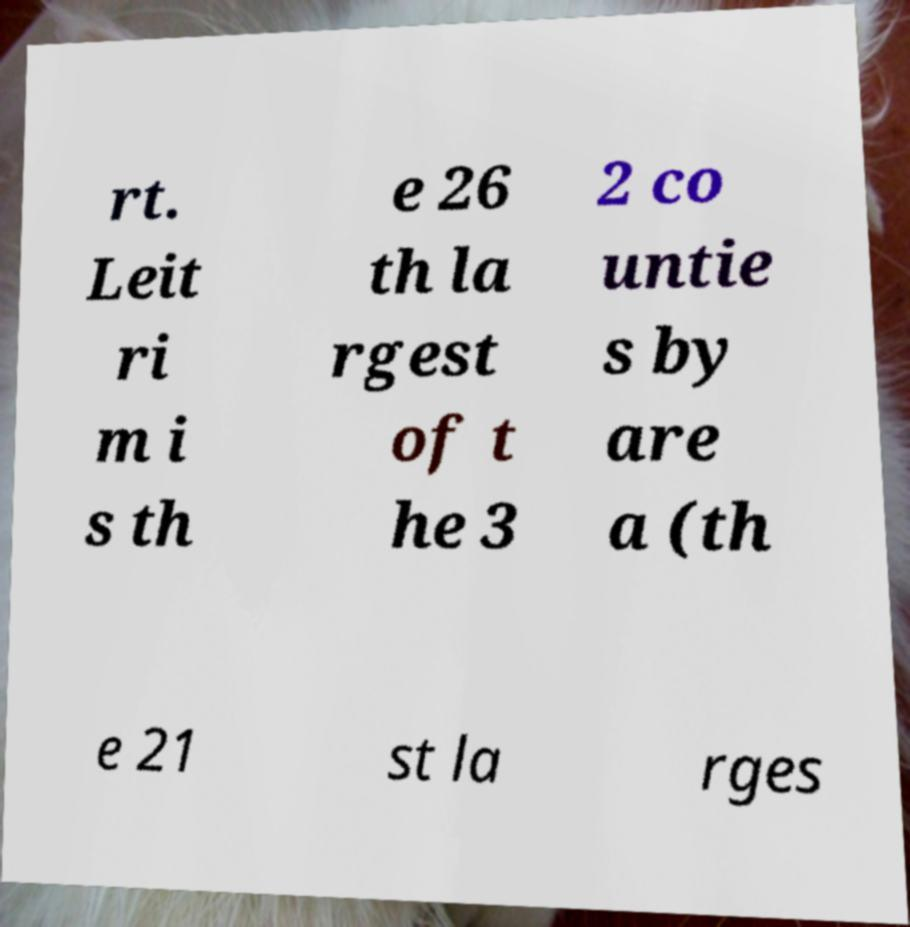There's text embedded in this image that I need extracted. Can you transcribe it verbatim? rt. Leit ri m i s th e 26 th la rgest of t he 3 2 co untie s by are a (th e 21 st la rges 